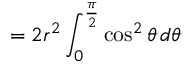Convert formula to latex. <formula><loc_0><loc_0><loc_500><loc_500>= 2 r ^ { 2 } \int _ { 0 } ^ { \frac { \pi } { 2 } } \cos ^ { 2 } \theta \, d \theta</formula> 